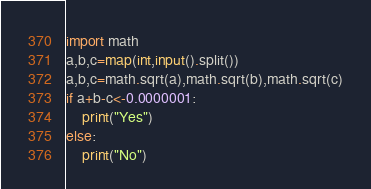Convert code to text. <code><loc_0><loc_0><loc_500><loc_500><_Python_>import math
a,b,c=map(int,input().split())
a,b,c=math.sqrt(a),math.sqrt(b),math.sqrt(c)
if a+b-c<-0.0000001:
    print("Yes")
else:
    print("No")</code> 